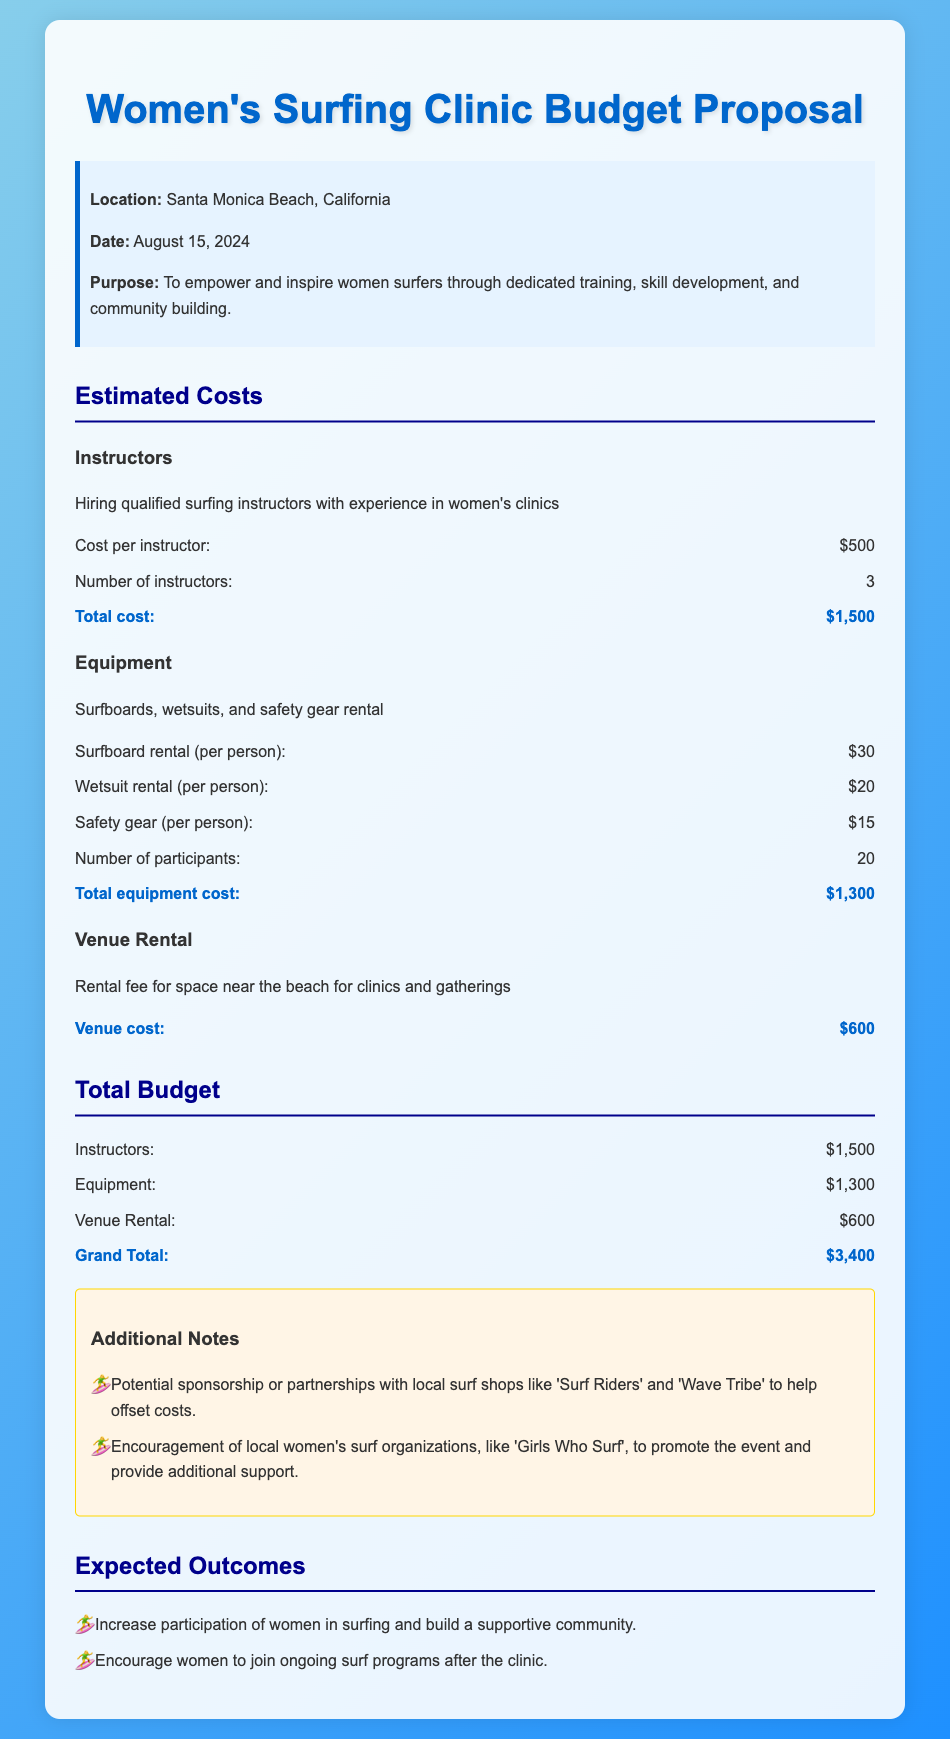What is the location of the clinic? The location of the clinic is specified in the document as Santa Monica Beach, California.
Answer: Santa Monica Beach, California What is the date of the clinic? The date of the clinic is mentioned as August 15, 2024.
Answer: August 15, 2024 How many instructors are being hired? The document states that 3 instructors will be hired for the clinic.
Answer: 3 What is the total cost for equipment? The total equipment cost is calculated in the document as $1,300.
Answer: $1,300 What is the venue cost? The document lists the venue cost as $600.
Answer: $600 What is the grand total budget for the clinic? The grand total is mentioned in the budget proposal as $3,400.
Answer: $3,400 What is the cost per instructor? The cost per instructor is specified as $500.
Answer: $500 What is one expected outcome of the clinic? The document states one expected outcome is to increase participation of women in surfing.
Answer: Increase participation of women in surfing What organization is mentioned to help promote the event? The note includes 'Girls Who Surf' as an organization to promote the event.
Answer: Girls Who Surf 